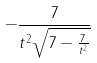<formula> <loc_0><loc_0><loc_500><loc_500>- \frac { 7 } { t ^ { 2 } \sqrt { 7 - \frac { 7 } { t ^ { 2 } } } }</formula> 